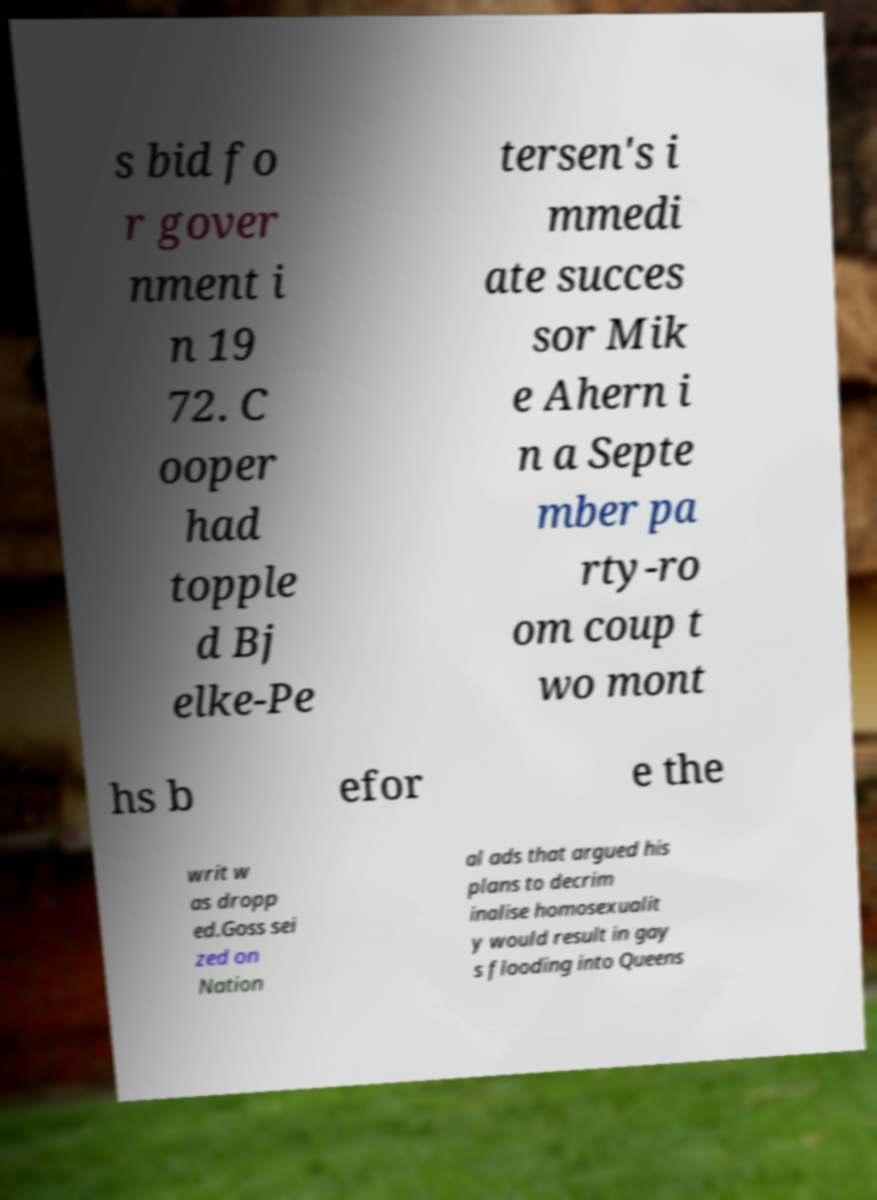There's text embedded in this image that I need extracted. Can you transcribe it verbatim? s bid fo r gover nment i n 19 72. C ooper had topple d Bj elke-Pe tersen's i mmedi ate succes sor Mik e Ahern i n a Septe mber pa rty-ro om coup t wo mont hs b efor e the writ w as dropp ed.Goss sei zed on Nation al ads that argued his plans to decrim inalise homosexualit y would result in gay s flooding into Queens 